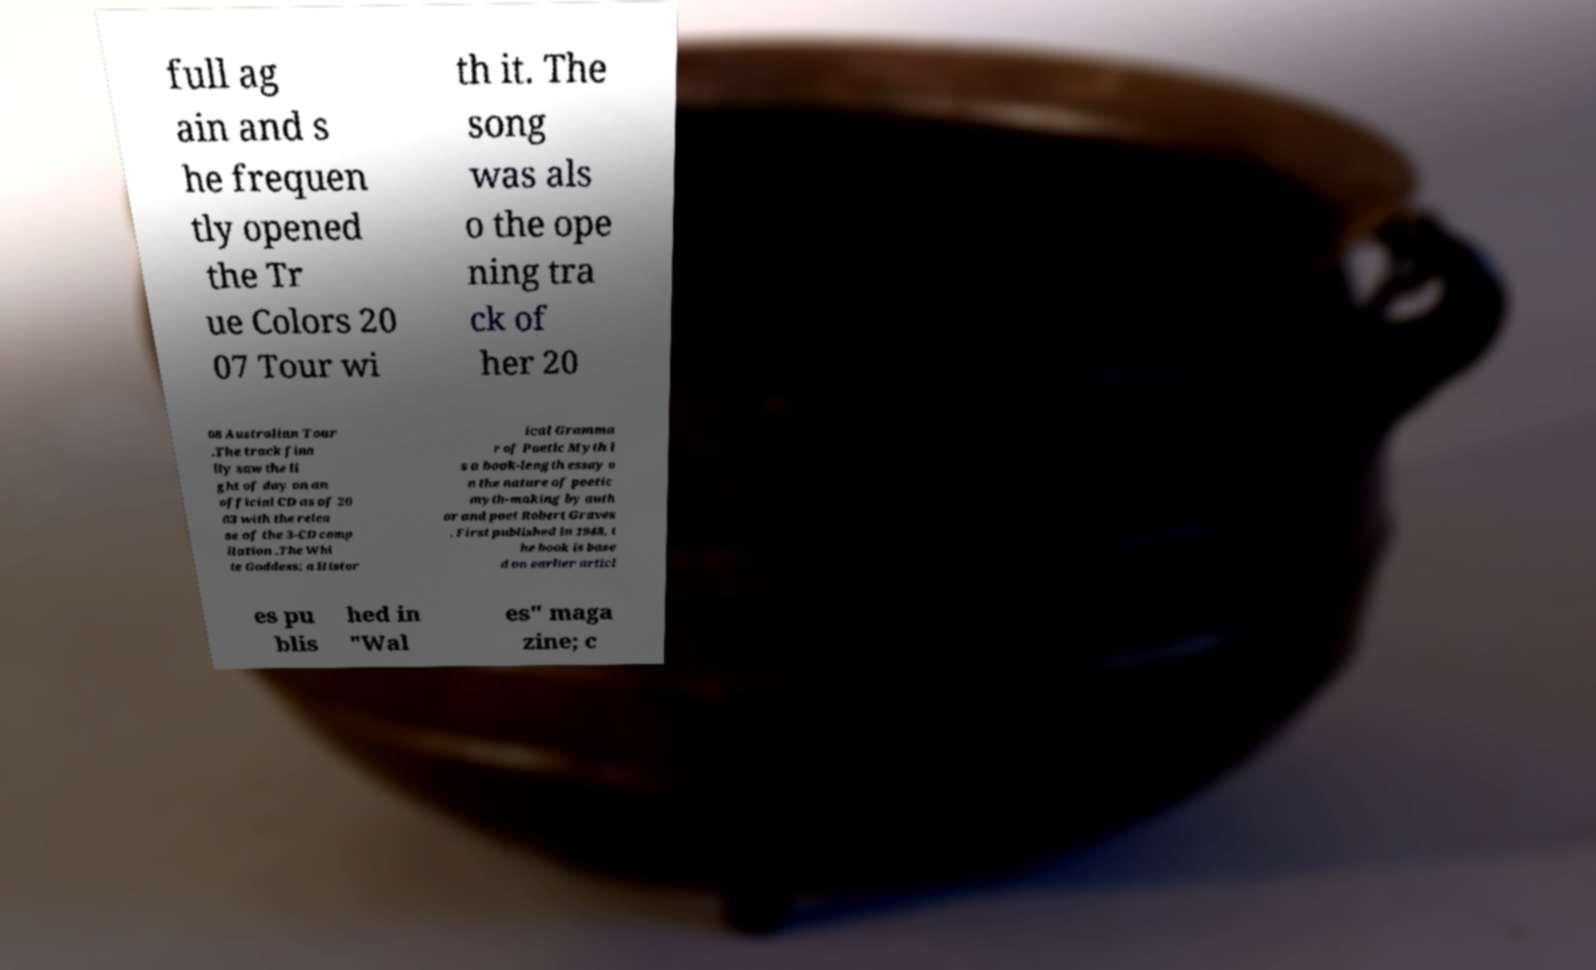Could you extract and type out the text from this image? full ag ain and s he frequen tly opened the Tr ue Colors 20 07 Tour wi th it. The song was als o the ope ning tra ck of her 20 08 Australian Tour .The track fina lly saw the li ght of day on an official CD as of 20 03 with the relea se of the 3-CD comp ilation .The Whi te Goddess: a Histor ical Gramma r of Poetic Myth i s a book-length essay o n the nature of poetic myth-making by auth or and poet Robert Graves . First published in 1948, t he book is base d on earlier articl es pu blis hed in "Wal es" maga zine; c 